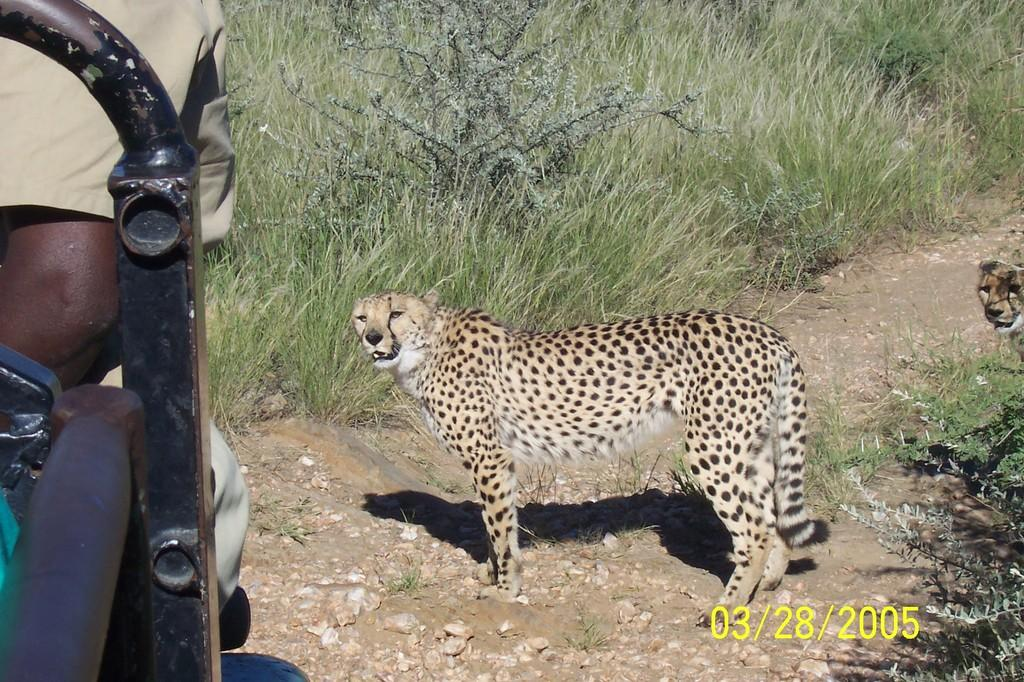How many leopards are in the image? There are two leopards in the image. What are the leopards doing in the image? The leopards are standing. Can you describe the person's location in the image? There is a person sitting inside a car in the image. What type of vegetation is visible in the background of the image? There is grass, plants, stones, and soil visible in the background of the image. How many chickens are visible in the image? There are no chickens present in the image. Is there a goat visible in the image? No, there is no goat present in the image. 